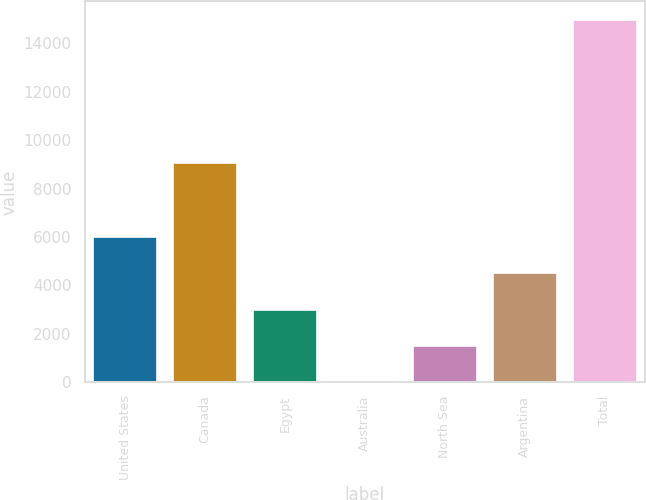Convert chart to OTSL. <chart><loc_0><loc_0><loc_500><loc_500><bar_chart><fcel>United States<fcel>Canada<fcel>Egypt<fcel>Australia<fcel>North Sea<fcel>Argentina<fcel>Total<nl><fcel>5996.6<fcel>9065<fcel>3004.8<fcel>13<fcel>1508.9<fcel>4500.7<fcel>14972<nl></chart> 